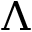Convert formula to latex. <formula><loc_0><loc_0><loc_500><loc_500>\Lambda</formula> 